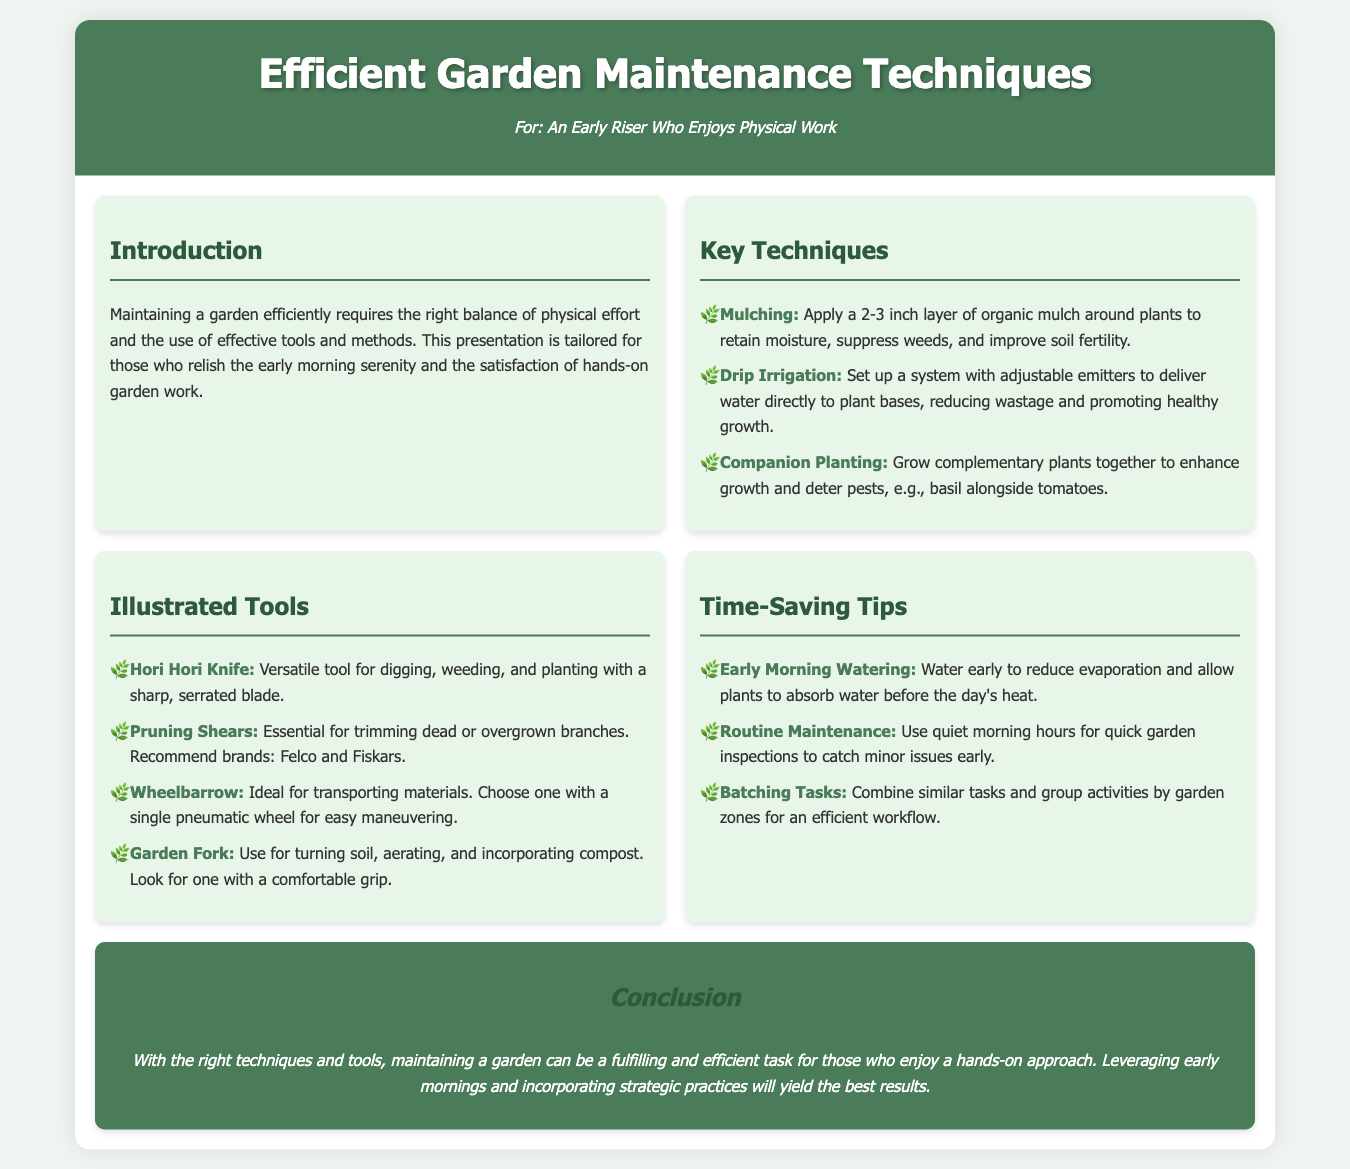What is the title of the presentation? The title is stated at the top of the document in the header section.
Answer: Efficient Garden Maintenance Techniques What is one key technique mentioned for garden maintenance? The document lists specific key techniques under the Key Techniques section.
Answer: Mulching Which tool is recommended for trimming branches? The recommendation is explicitly mentioned in the Illustrated Tools section.
Answer: Pruning Shears What is one time-saving tip suggested for gardening? The document specifies tips under the Time-Saving Tips section.
Answer: Early Morning Watering How many key techniques are listed in the document? The number of techniques can be counted from the Key Techniques section.
Answer: Three What should be applied around plants to retain moisture? This information is found in the Key Techniques section regarding mulching.
Answer: Organic mulch Which brand of pruning shears is mentioned? The document specifies brands in the Illustrated Tools section.
Answer: Felco What color is the header background? The color is described in the CSS style, which defines the appearance of the header.
Answer: Green What is the overall theme of the presentation? The introduction section provides insight into the focus of the presentation.
Answer: Garden Maintenance Techniques 